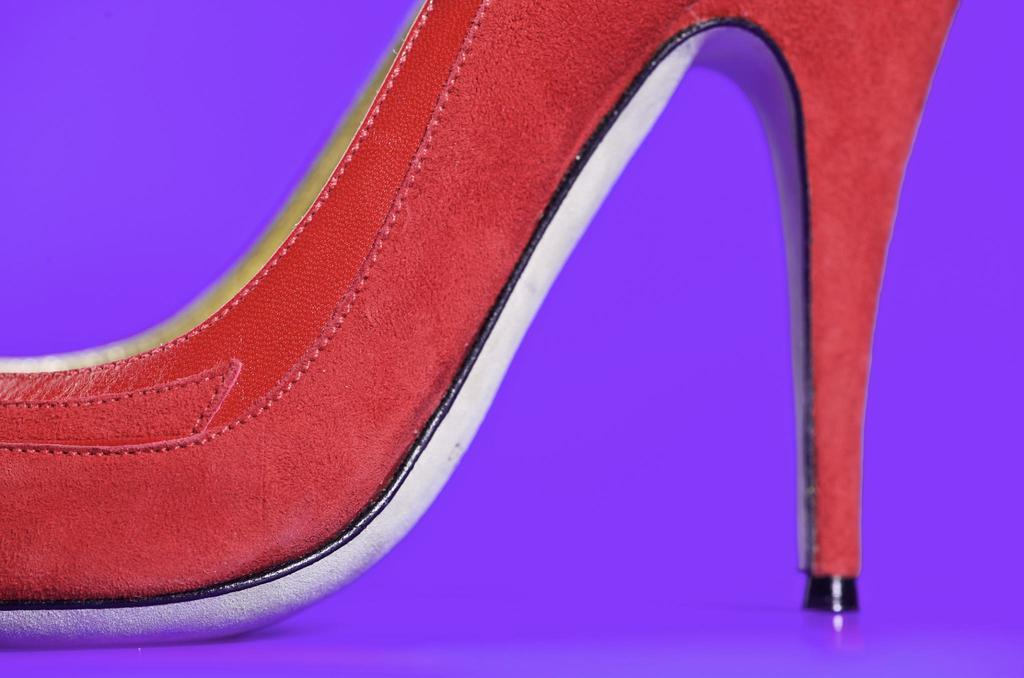What type of object is present in the image? There is footwear in the image. Can you describe the position of the footwear in the image? The footwear is on an object. How many jellyfish can be seen in the image? There are no jellyfish present in the image. What type of pocket is visible in the image? There is no pocket visible in the image. 